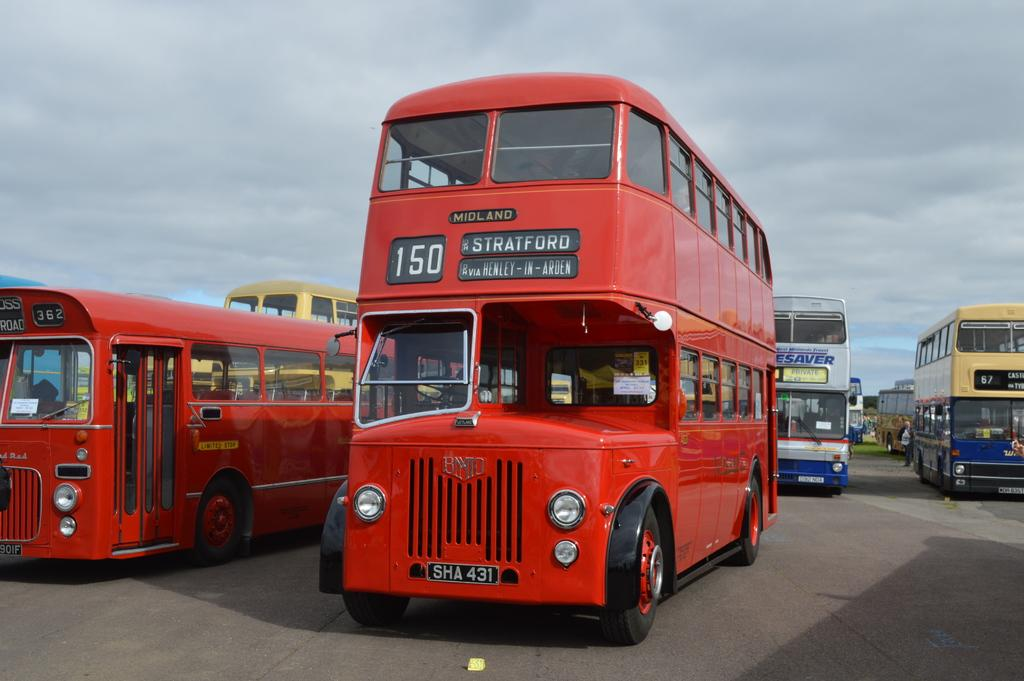What is present on the path in the image? There are vehicles parked on the path in the image. What can be seen in the background of the image? The sky is visible in the background of the image. How would you describe the sky in the image? The sky appears to be cloudy in the image. What type of experience does the death in the image have? There is no death present in the image, so it is not possible to answer that question. 